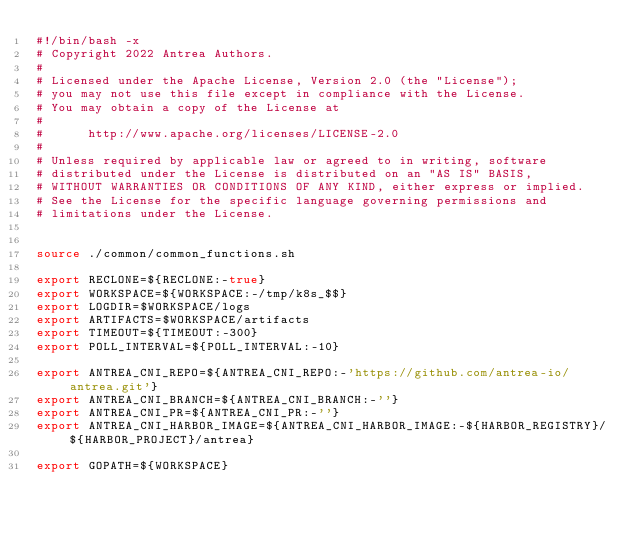<code> <loc_0><loc_0><loc_500><loc_500><_Bash_>#!/bin/bash -x
# Copyright 2022 Antrea Authors.
#
# Licensed under the Apache License, Version 2.0 (the "License");
# you may not use this file except in compliance with the License.
# You may obtain a copy of the License at
#
#      http://www.apache.org/licenses/LICENSE-2.0
#
# Unless required by applicable law or agreed to in writing, software
# distributed under the License is distributed on an "AS IS" BASIS,
# WITHOUT WARRANTIES OR CONDITIONS OF ANY KIND, either express or implied.
# See the License for the specific language governing permissions and
# limitations under the License.


source ./common/common_functions.sh

export RECLONE=${RECLONE:-true}
export WORKSPACE=${WORKSPACE:-/tmp/k8s_$$}
export LOGDIR=$WORKSPACE/logs
export ARTIFACTS=$WORKSPACE/artifacts
export TIMEOUT=${TIMEOUT:-300}
export POLL_INTERVAL=${POLL_INTERVAL:-10}

export ANTREA_CNI_REPO=${ANTREA_CNI_REPO:-'https://github.com/antrea-io/antrea.git'}
export ANTREA_CNI_BRANCH=${ANTREA_CNI_BRANCH:-''}
export ANTREA_CNI_PR=${ANTREA_CNI_PR:-''}
export ANTREA_CNI_HARBOR_IMAGE=${ANTREA_CNI_HARBOR_IMAGE:-${HARBOR_REGISTRY}/${HARBOR_PROJECT}/antrea}

export GOPATH=${WORKSPACE}</code> 